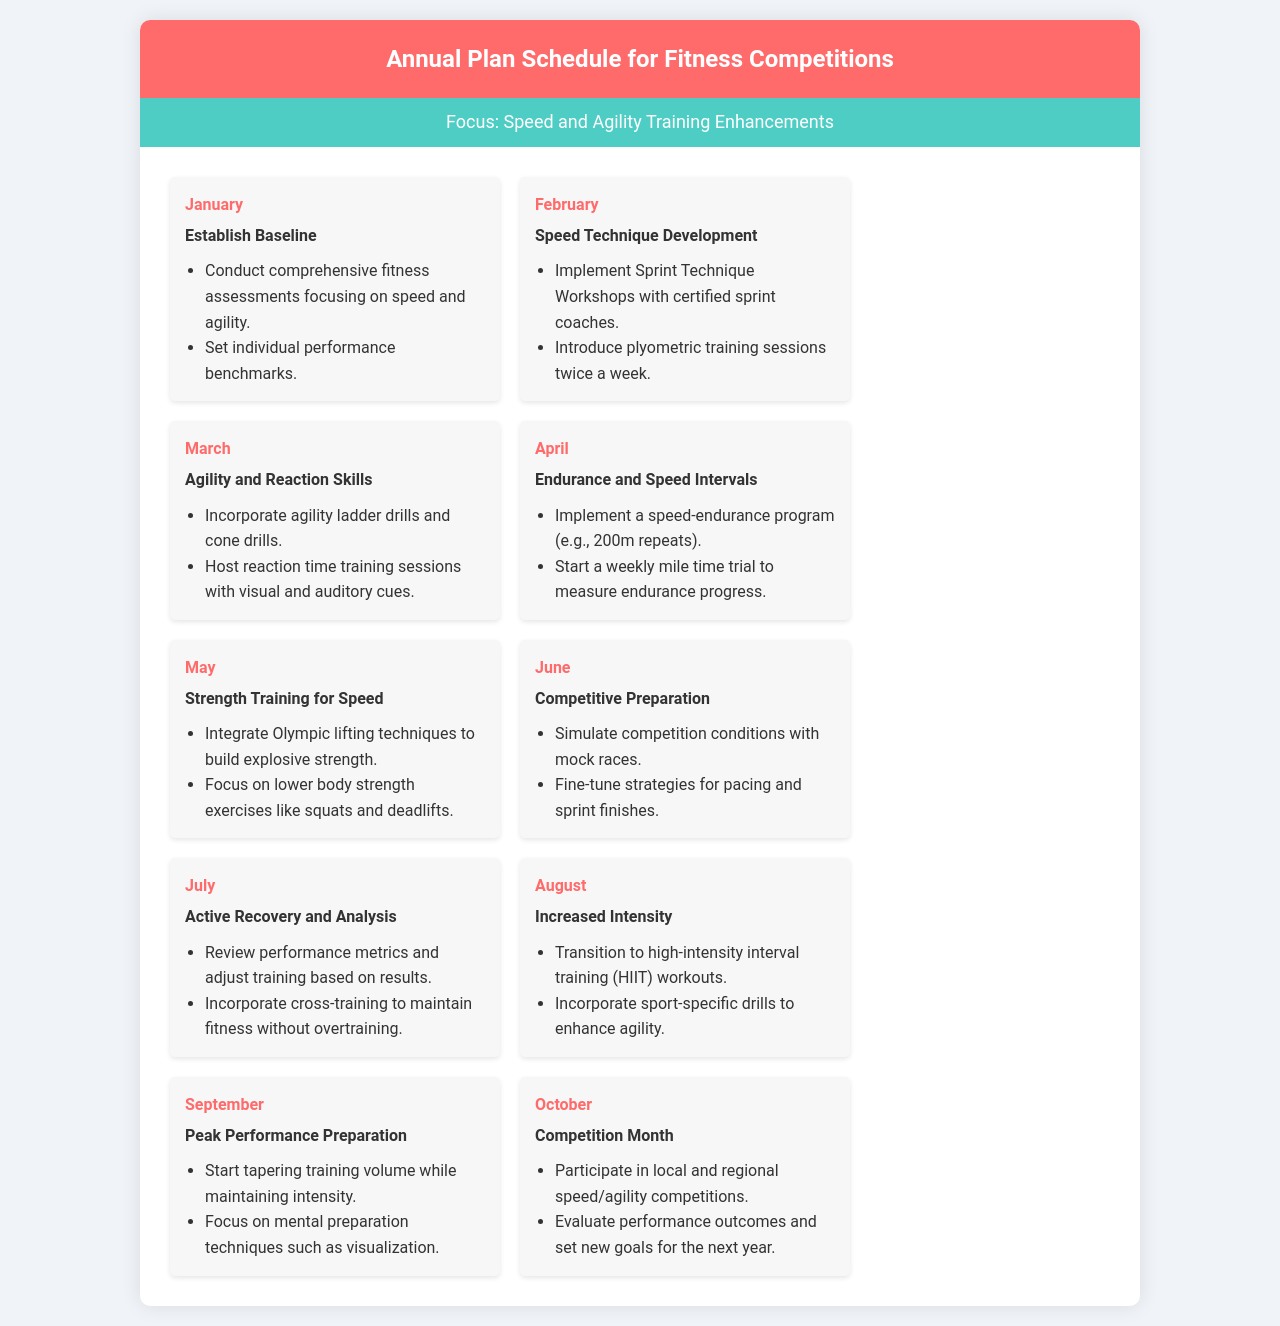What is the goal for January? The goal for January is to establish baseline performance metrics for speed and agility.
Answer: Establish Baseline How many competitions are scheduled in October? The document states the participation in local and regional competitions in October, but does not specify a number.
Answer: Not specified What type of training is introduced in February? The training introduced in February involves sprint technique workshops and plyometric training sessions.
Answer: Sprint Technique Development What training focus is mentioned in March? The focus for March is on improving agility and reaction skills through specific drills.
Answer: Agility and Reaction Skills What is the main goal for June? The main goal for June is to prepare for competitions by simulating conditions and strategies.
Answer: Competitive Preparation What type of training begins in August? The type of training that begins in August is high-intensity interval training (HIIT).
Answer: Increased Intensity In which month do participants start tapering training volume? Participants start tapering training volume in September as they prepare for competition.
Answer: September What metric is reviewed in July? In July, performance metrics are reviewed in order to adjust training.
Answer: Performance metrics 